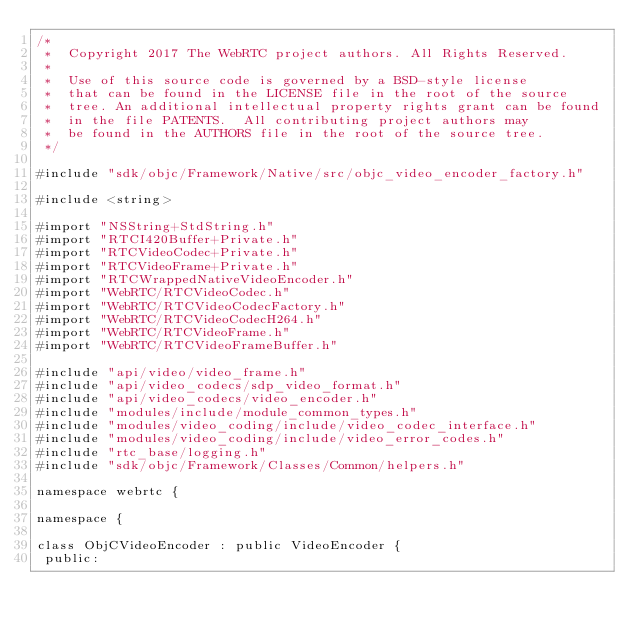<code> <loc_0><loc_0><loc_500><loc_500><_ObjectiveC_>/*
 *  Copyright 2017 The WebRTC project authors. All Rights Reserved.
 *
 *  Use of this source code is governed by a BSD-style license
 *  that can be found in the LICENSE file in the root of the source
 *  tree. An additional intellectual property rights grant can be found
 *  in the file PATENTS.  All contributing project authors may
 *  be found in the AUTHORS file in the root of the source tree.
 */

#include "sdk/objc/Framework/Native/src/objc_video_encoder_factory.h"

#include <string>

#import "NSString+StdString.h"
#import "RTCI420Buffer+Private.h"
#import "RTCVideoCodec+Private.h"
#import "RTCVideoFrame+Private.h"
#import "RTCWrappedNativeVideoEncoder.h"
#import "WebRTC/RTCVideoCodec.h"
#import "WebRTC/RTCVideoCodecFactory.h"
#import "WebRTC/RTCVideoCodecH264.h"
#import "WebRTC/RTCVideoFrame.h"
#import "WebRTC/RTCVideoFrameBuffer.h"

#include "api/video/video_frame.h"
#include "api/video_codecs/sdp_video_format.h"
#include "api/video_codecs/video_encoder.h"
#include "modules/include/module_common_types.h"
#include "modules/video_coding/include/video_codec_interface.h"
#include "modules/video_coding/include/video_error_codes.h"
#include "rtc_base/logging.h"
#include "sdk/objc/Framework/Classes/Common/helpers.h"

namespace webrtc {

namespace {

class ObjCVideoEncoder : public VideoEncoder {
 public:</code> 